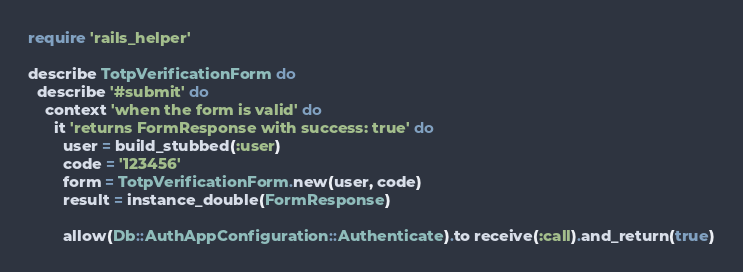<code> <loc_0><loc_0><loc_500><loc_500><_Ruby_>require 'rails_helper'

describe TotpVerificationForm do
  describe '#submit' do
    context 'when the form is valid' do
      it 'returns FormResponse with success: true' do
        user = build_stubbed(:user)
        code = '123456'
        form = TotpVerificationForm.new(user, code)
        result = instance_double(FormResponse)

        allow(Db::AuthAppConfiguration::Authenticate).to receive(:call).and_return(true)
</code> 